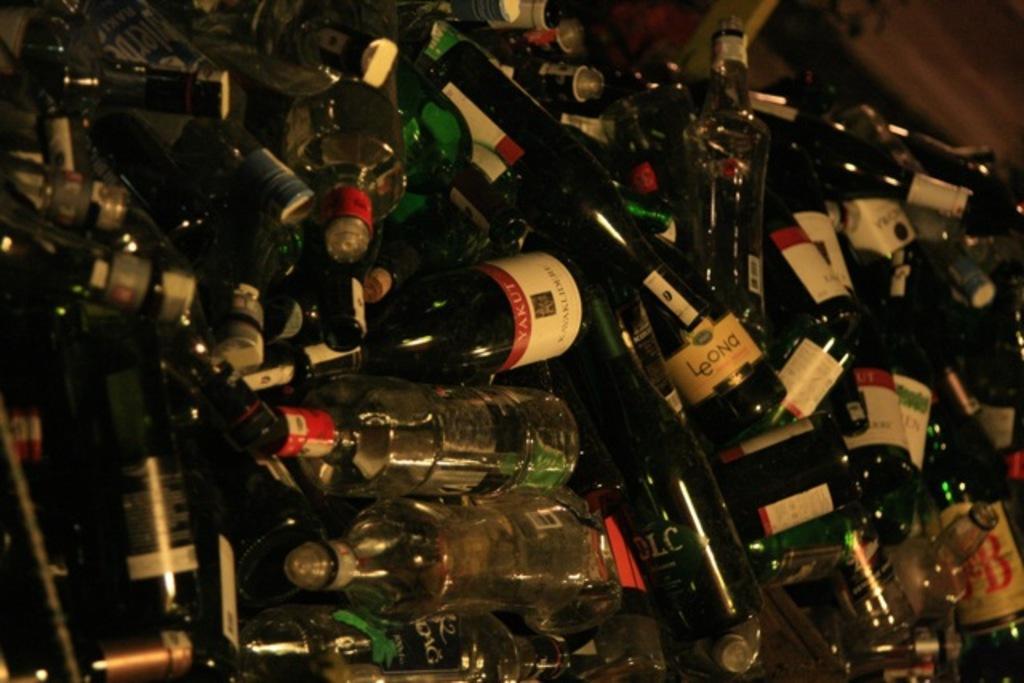In one or two sentences, can you explain what this image depicts? In this image I can see many wine bottles. 